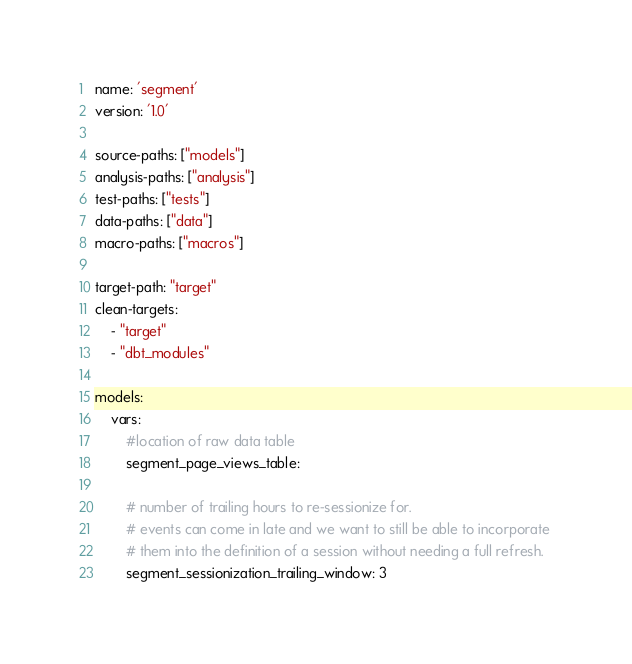Convert code to text. <code><loc_0><loc_0><loc_500><loc_500><_YAML_>name: 'segment'
version: '1.0'

source-paths: ["models"]
analysis-paths: ["analysis"] 
test-paths: ["tests"]
data-paths: ["data"]
macro-paths: ["macros"]

target-path: "target"
clean-targets:
    - "target"
    - "dbt_modules"

models:
    vars:
        #location of raw data table
        segment_page_views_table: 
        
        # number of trailing hours to re-sessionize for. 
        # events can come in late and we want to still be able to incorporate 
        # them into the definition of a session without needing a full refresh.
        segment_sessionization_trailing_window: 3 </code> 